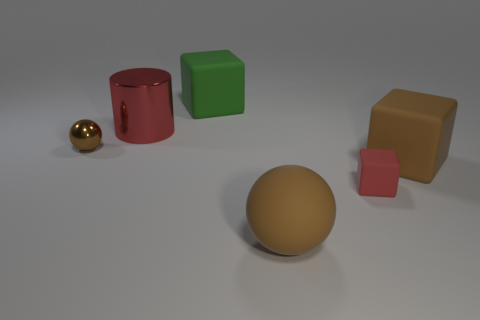Add 3 small brown things. How many objects exist? 9 Subtract all spheres. How many objects are left? 4 Subtract all big red metallic blocks. Subtract all cubes. How many objects are left? 3 Add 6 tiny red matte blocks. How many tiny red matte blocks are left? 7 Add 3 small brown rubber cylinders. How many small brown rubber cylinders exist? 3 Subtract 0 purple cubes. How many objects are left? 6 